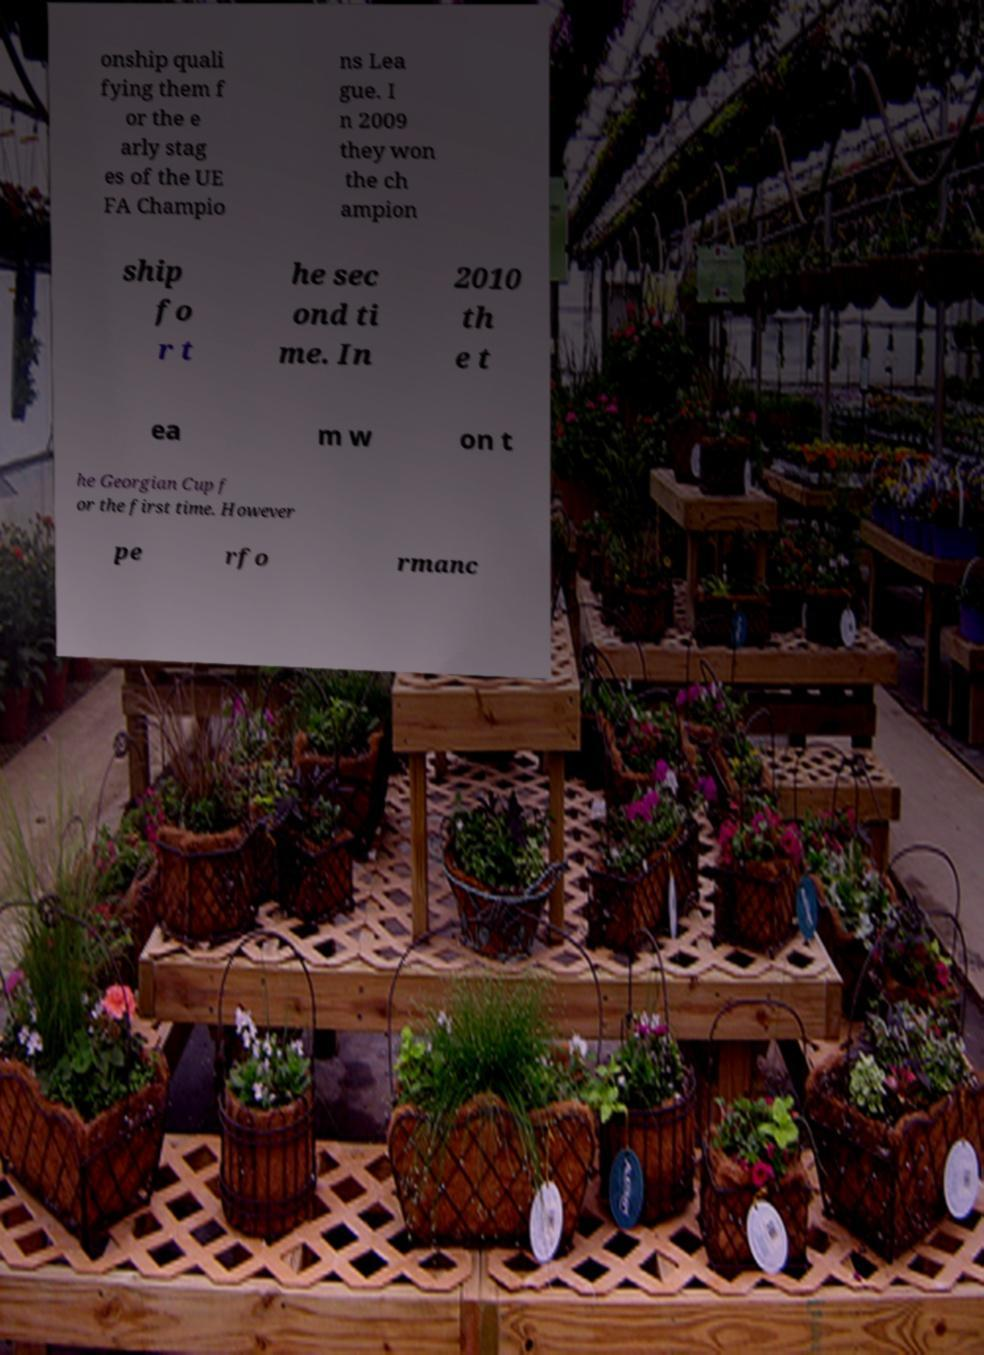Can you read and provide the text displayed in the image?This photo seems to have some interesting text. Can you extract and type it out for me? onship quali fying them f or the e arly stag es of the UE FA Champio ns Lea gue. I n 2009 they won the ch ampion ship fo r t he sec ond ti me. In 2010 th e t ea m w on t he Georgian Cup f or the first time. However pe rfo rmanc 